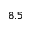Convert formula to latex. <formula><loc_0><loc_0><loc_500><loc_500>8 . 5</formula> 